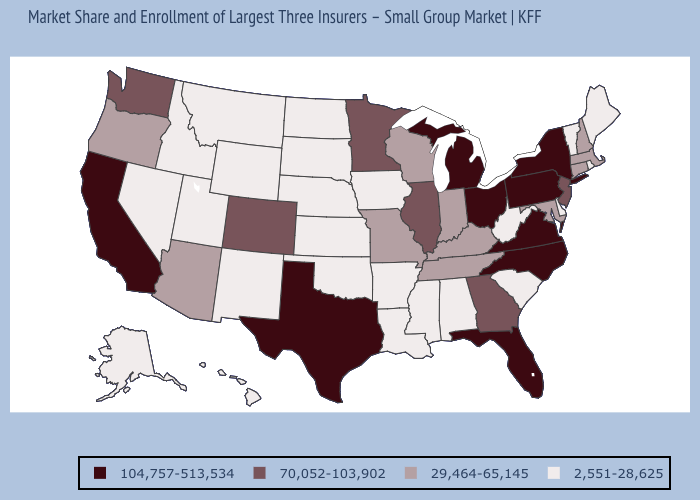Name the states that have a value in the range 104,757-513,534?
Give a very brief answer. California, Florida, Michigan, New York, North Carolina, Ohio, Pennsylvania, Texas, Virginia. Does Maine have a lower value than Florida?
Keep it brief. Yes. Name the states that have a value in the range 70,052-103,902?
Be succinct. Colorado, Georgia, Illinois, Minnesota, New Jersey, Washington. Does the first symbol in the legend represent the smallest category?
Answer briefly. No. Name the states that have a value in the range 29,464-65,145?
Quick response, please. Arizona, Connecticut, Indiana, Kentucky, Maryland, Massachusetts, Missouri, New Hampshire, Oregon, Tennessee, Wisconsin. What is the value of Vermont?
Concise answer only. 2,551-28,625. Does South Dakota have a higher value than Texas?
Concise answer only. No. Name the states that have a value in the range 2,551-28,625?
Write a very short answer. Alabama, Alaska, Arkansas, Delaware, Hawaii, Idaho, Iowa, Kansas, Louisiana, Maine, Mississippi, Montana, Nebraska, Nevada, New Mexico, North Dakota, Oklahoma, Rhode Island, South Carolina, South Dakota, Utah, Vermont, West Virginia, Wyoming. Does the first symbol in the legend represent the smallest category?
Short answer required. No. Does Tennessee have the lowest value in the South?
Give a very brief answer. No. What is the highest value in the West ?
Short answer required. 104,757-513,534. What is the lowest value in states that border Wisconsin?
Write a very short answer. 2,551-28,625. Does Rhode Island have the highest value in the USA?
Quick response, please. No. Name the states that have a value in the range 2,551-28,625?
Quick response, please. Alabama, Alaska, Arkansas, Delaware, Hawaii, Idaho, Iowa, Kansas, Louisiana, Maine, Mississippi, Montana, Nebraska, Nevada, New Mexico, North Dakota, Oklahoma, Rhode Island, South Carolina, South Dakota, Utah, Vermont, West Virginia, Wyoming. Does New Mexico have the lowest value in the West?
Write a very short answer. Yes. 